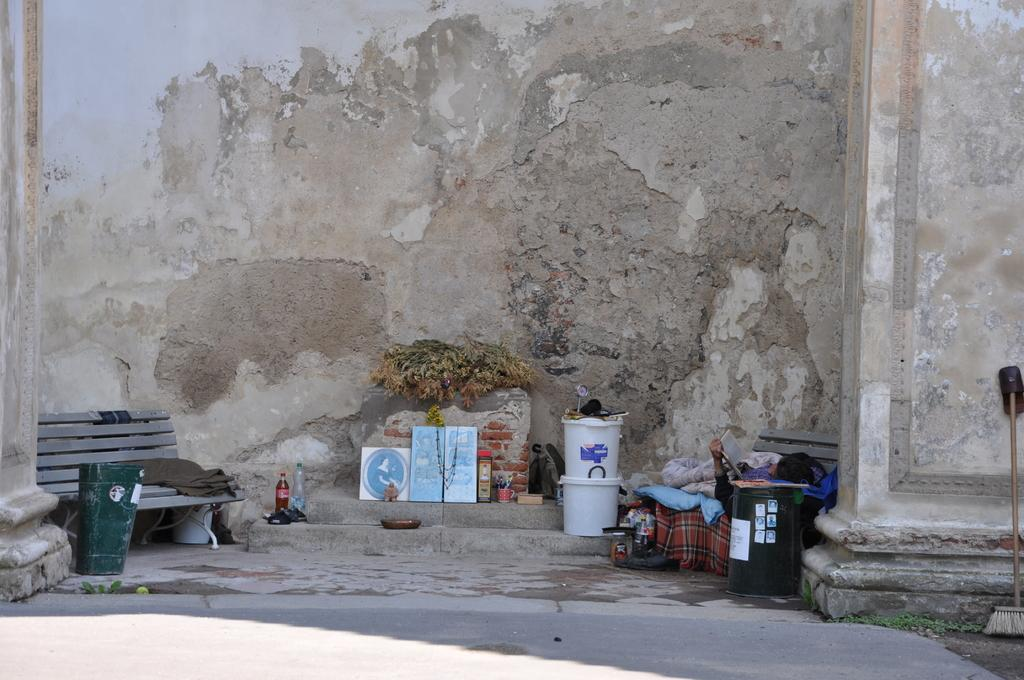What type of seating is available in the image? There are benches in the image. What is the color of the box in the image? There is a green box in the image. What is the person holding in the image? The person is holding a book in the image. What type of containers can be seen in the image? There are bottles in the image. What type of clothing is visible in the image? There are clothes in the image. What is the person doing in the image? There is a person sleeping and holding a book in the image. What is on the floor in the image? There are objects on the floor in the image. What type of architectural features are present in the image? There is a wall and a pillar in the image. How many buns are on the person's head in the image? There are no buns present on the person's head in the image. What type of doll is sitting on the bench in the image? There is no doll present on the bench in the image. 